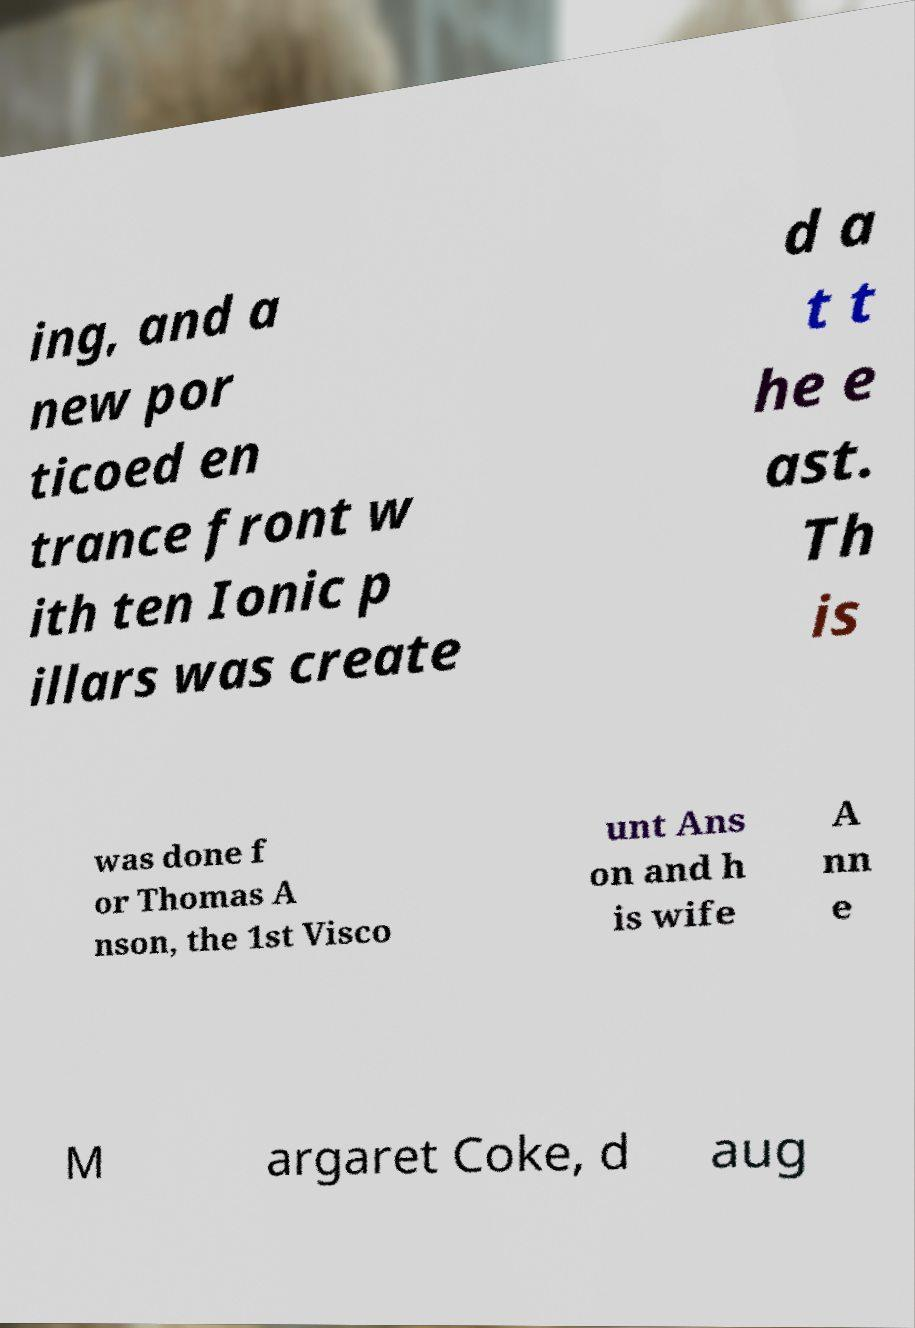Could you extract and type out the text from this image? ing, and a new por ticoed en trance front w ith ten Ionic p illars was create d a t t he e ast. Th is was done f or Thomas A nson, the 1st Visco unt Ans on and h is wife A nn e M argaret Coke, d aug 